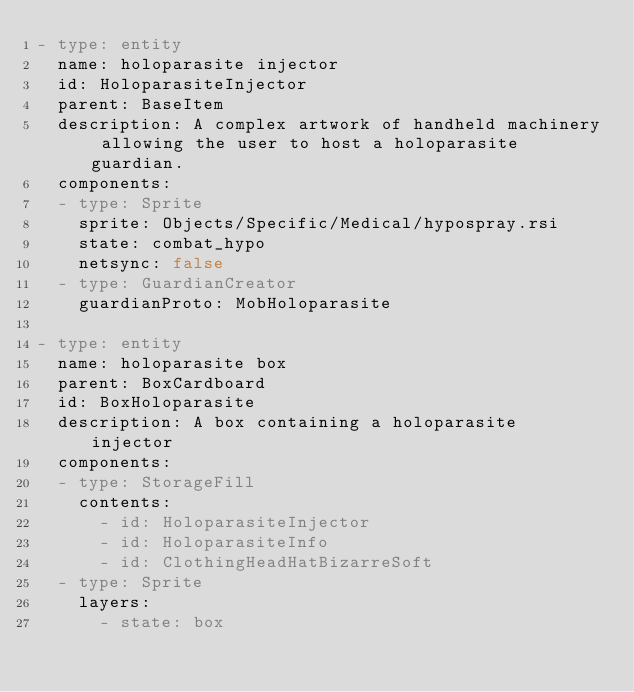Convert code to text. <code><loc_0><loc_0><loc_500><loc_500><_YAML_>- type: entity
  name: holoparasite injector
  id: HoloparasiteInjector
  parent: BaseItem
  description: A complex artwork of handheld machinery allowing the user to host a holoparasite guardian.
  components:
  - type: Sprite
    sprite: Objects/Specific/Medical/hypospray.rsi
    state: combat_hypo
    netsync: false
  - type: GuardianCreator
    guardianProto: MobHoloparasite

- type: entity
  name: holoparasite box
  parent: BoxCardboard
  id: BoxHoloparasite
  description: A box containing a holoparasite injector
  components:
  - type: StorageFill
    contents:
      - id: HoloparasiteInjector
      - id: HoloparasiteInfo
      - id: ClothingHeadHatBizarreSoft
  - type: Sprite
    layers:
      - state: box
</code> 